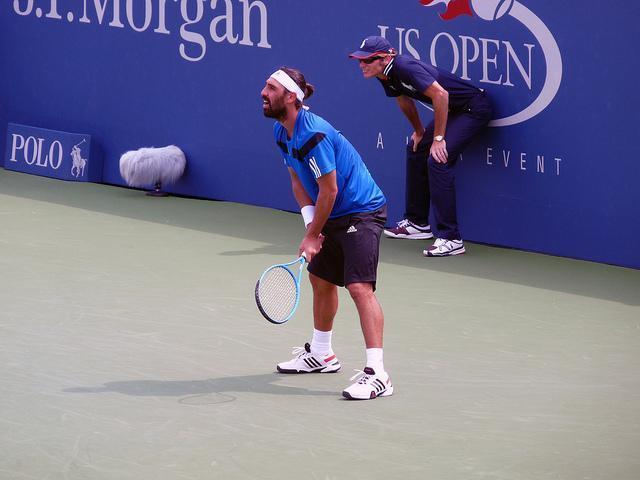How many people are in the picture?
Give a very brief answer. 2. 